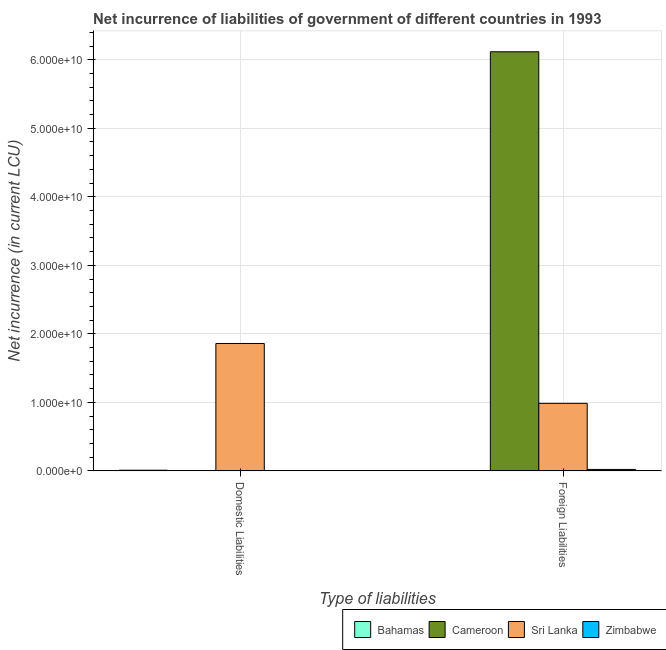How many different coloured bars are there?
Give a very brief answer. 4. How many groups of bars are there?
Provide a short and direct response. 2. Are the number of bars on each tick of the X-axis equal?
Provide a short and direct response. No. How many bars are there on the 2nd tick from the left?
Give a very brief answer. 3. How many bars are there on the 2nd tick from the right?
Your answer should be very brief. 2. What is the label of the 1st group of bars from the left?
Keep it short and to the point. Domestic Liabilities. What is the net incurrence of domestic liabilities in Bahamas?
Offer a terse response. 9.90e+07. Across all countries, what is the maximum net incurrence of domestic liabilities?
Provide a short and direct response. 1.86e+1. Across all countries, what is the minimum net incurrence of foreign liabilities?
Give a very brief answer. 0. In which country was the net incurrence of domestic liabilities maximum?
Offer a very short reply. Sri Lanka. What is the total net incurrence of foreign liabilities in the graph?
Your response must be concise. 7.12e+1. What is the difference between the net incurrence of foreign liabilities in Sri Lanka and that in Zimbabwe?
Your response must be concise. 9.64e+09. What is the average net incurrence of domestic liabilities per country?
Offer a terse response. 4.67e+09. What is the difference between the net incurrence of domestic liabilities and net incurrence of foreign liabilities in Sri Lanka?
Provide a succinct answer. 8.74e+09. In how many countries, is the net incurrence of foreign liabilities greater than 44000000000 LCU?
Keep it short and to the point. 1. What is the ratio of the net incurrence of domestic liabilities in Sri Lanka to that in Bahamas?
Your answer should be compact. 187.82. Is the net incurrence of domestic liabilities in Sri Lanka less than that in Bahamas?
Give a very brief answer. No. In how many countries, is the net incurrence of foreign liabilities greater than the average net incurrence of foreign liabilities taken over all countries?
Ensure brevity in your answer.  1. What is the difference between two consecutive major ticks on the Y-axis?
Your answer should be compact. 1.00e+1. Are the values on the major ticks of Y-axis written in scientific E-notation?
Your answer should be compact. Yes. Does the graph contain any zero values?
Keep it short and to the point. Yes. Does the graph contain grids?
Provide a short and direct response. Yes. How are the legend labels stacked?
Your answer should be very brief. Horizontal. What is the title of the graph?
Provide a succinct answer. Net incurrence of liabilities of government of different countries in 1993. What is the label or title of the X-axis?
Give a very brief answer. Type of liabilities. What is the label or title of the Y-axis?
Give a very brief answer. Net incurrence (in current LCU). What is the Net incurrence (in current LCU) in Bahamas in Domestic Liabilities?
Provide a succinct answer. 9.90e+07. What is the Net incurrence (in current LCU) of Sri Lanka in Domestic Liabilities?
Offer a very short reply. 1.86e+1. What is the Net incurrence (in current LCU) of Zimbabwe in Domestic Liabilities?
Keep it short and to the point. 0. What is the Net incurrence (in current LCU) in Bahamas in Foreign Liabilities?
Provide a succinct answer. 0. What is the Net incurrence (in current LCU) in Cameroon in Foreign Liabilities?
Make the answer very short. 6.12e+1. What is the Net incurrence (in current LCU) of Sri Lanka in Foreign Liabilities?
Offer a terse response. 9.86e+09. What is the Net incurrence (in current LCU) of Zimbabwe in Foreign Liabilities?
Provide a succinct answer. 2.11e+08. Across all Type of liabilities, what is the maximum Net incurrence (in current LCU) in Bahamas?
Ensure brevity in your answer.  9.90e+07. Across all Type of liabilities, what is the maximum Net incurrence (in current LCU) in Cameroon?
Ensure brevity in your answer.  6.12e+1. Across all Type of liabilities, what is the maximum Net incurrence (in current LCU) of Sri Lanka?
Provide a short and direct response. 1.86e+1. Across all Type of liabilities, what is the maximum Net incurrence (in current LCU) in Zimbabwe?
Your answer should be very brief. 2.11e+08. Across all Type of liabilities, what is the minimum Net incurrence (in current LCU) of Bahamas?
Offer a very short reply. 0. Across all Type of liabilities, what is the minimum Net incurrence (in current LCU) of Cameroon?
Keep it short and to the point. 0. Across all Type of liabilities, what is the minimum Net incurrence (in current LCU) of Sri Lanka?
Provide a succinct answer. 9.86e+09. Across all Type of liabilities, what is the minimum Net incurrence (in current LCU) of Zimbabwe?
Your response must be concise. 0. What is the total Net incurrence (in current LCU) in Bahamas in the graph?
Keep it short and to the point. 9.90e+07. What is the total Net incurrence (in current LCU) of Cameroon in the graph?
Offer a very short reply. 6.12e+1. What is the total Net incurrence (in current LCU) of Sri Lanka in the graph?
Keep it short and to the point. 2.84e+1. What is the total Net incurrence (in current LCU) of Zimbabwe in the graph?
Provide a short and direct response. 2.11e+08. What is the difference between the Net incurrence (in current LCU) of Sri Lanka in Domestic Liabilities and that in Foreign Liabilities?
Your answer should be very brief. 8.74e+09. What is the difference between the Net incurrence (in current LCU) of Bahamas in Domestic Liabilities and the Net incurrence (in current LCU) of Cameroon in Foreign Liabilities?
Your answer should be very brief. -6.11e+1. What is the difference between the Net incurrence (in current LCU) of Bahamas in Domestic Liabilities and the Net incurrence (in current LCU) of Sri Lanka in Foreign Liabilities?
Your response must be concise. -9.76e+09. What is the difference between the Net incurrence (in current LCU) in Bahamas in Domestic Liabilities and the Net incurrence (in current LCU) in Zimbabwe in Foreign Liabilities?
Provide a succinct answer. -1.12e+08. What is the difference between the Net incurrence (in current LCU) in Sri Lanka in Domestic Liabilities and the Net incurrence (in current LCU) in Zimbabwe in Foreign Liabilities?
Make the answer very short. 1.84e+1. What is the average Net incurrence (in current LCU) of Bahamas per Type of liabilities?
Keep it short and to the point. 4.95e+07. What is the average Net incurrence (in current LCU) in Cameroon per Type of liabilities?
Your answer should be compact. 3.06e+1. What is the average Net incurrence (in current LCU) of Sri Lanka per Type of liabilities?
Offer a very short reply. 1.42e+1. What is the average Net incurrence (in current LCU) of Zimbabwe per Type of liabilities?
Give a very brief answer. 1.06e+08. What is the difference between the Net incurrence (in current LCU) in Bahamas and Net incurrence (in current LCU) in Sri Lanka in Domestic Liabilities?
Ensure brevity in your answer.  -1.85e+1. What is the difference between the Net incurrence (in current LCU) in Cameroon and Net incurrence (in current LCU) in Sri Lanka in Foreign Liabilities?
Give a very brief answer. 5.13e+1. What is the difference between the Net incurrence (in current LCU) of Cameroon and Net incurrence (in current LCU) of Zimbabwe in Foreign Liabilities?
Offer a terse response. 6.09e+1. What is the difference between the Net incurrence (in current LCU) in Sri Lanka and Net incurrence (in current LCU) in Zimbabwe in Foreign Liabilities?
Your answer should be compact. 9.64e+09. What is the ratio of the Net incurrence (in current LCU) of Sri Lanka in Domestic Liabilities to that in Foreign Liabilities?
Offer a terse response. 1.89. What is the difference between the highest and the second highest Net incurrence (in current LCU) of Sri Lanka?
Offer a very short reply. 8.74e+09. What is the difference between the highest and the lowest Net incurrence (in current LCU) of Bahamas?
Offer a terse response. 9.90e+07. What is the difference between the highest and the lowest Net incurrence (in current LCU) of Cameroon?
Keep it short and to the point. 6.12e+1. What is the difference between the highest and the lowest Net incurrence (in current LCU) in Sri Lanka?
Give a very brief answer. 8.74e+09. What is the difference between the highest and the lowest Net incurrence (in current LCU) in Zimbabwe?
Your response must be concise. 2.11e+08. 